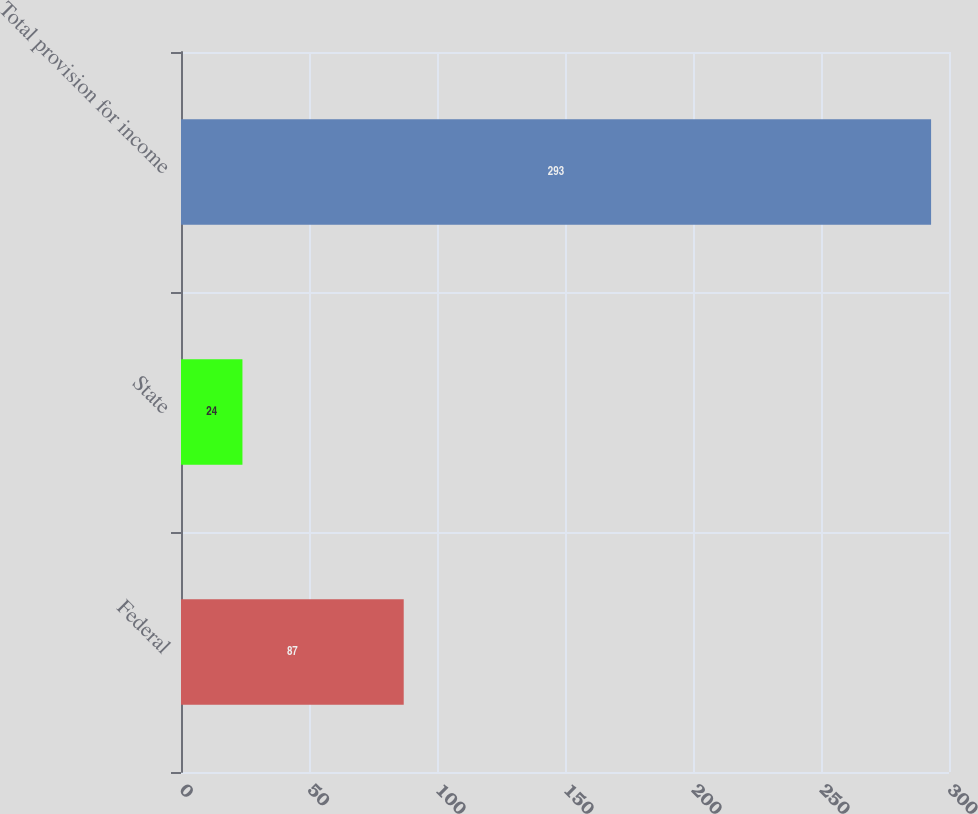<chart> <loc_0><loc_0><loc_500><loc_500><bar_chart><fcel>Federal<fcel>State<fcel>Total provision for income<nl><fcel>87<fcel>24<fcel>293<nl></chart> 